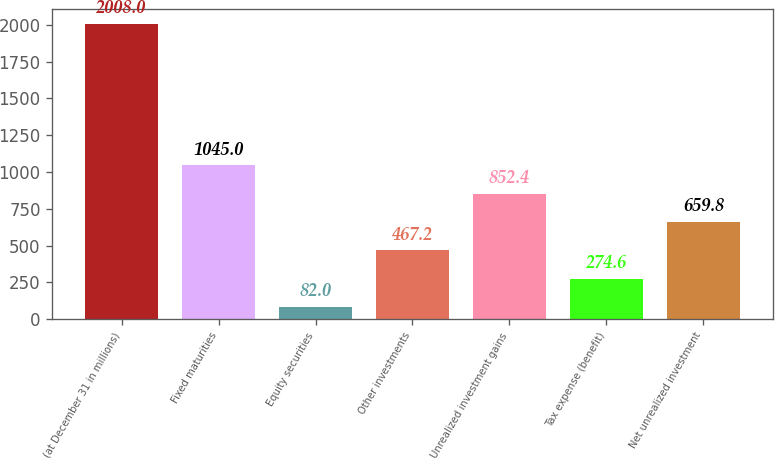Convert chart to OTSL. <chart><loc_0><loc_0><loc_500><loc_500><bar_chart><fcel>(at December 31 in millions)<fcel>Fixed maturities<fcel>Equity securities<fcel>Other investments<fcel>Unrealized investment gains<fcel>Tax expense (benefit)<fcel>Net unrealized investment<nl><fcel>2008<fcel>1045<fcel>82<fcel>467.2<fcel>852.4<fcel>274.6<fcel>659.8<nl></chart> 